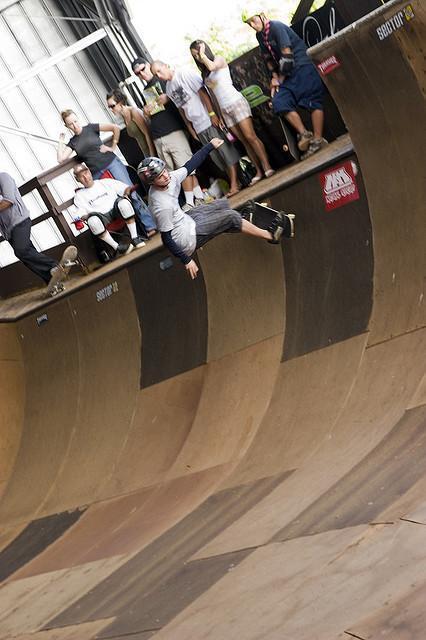What is the man skateboarding on?
Make your selection and explain in format: 'Answer: answer
Rationale: rationale.'
Options: Half pipe, training ramp, full pipe, tech deck. Answer: half pipe.
Rationale: The skating surface curves sharply upward at least at one end of it, and is roughly the height of an adult person at its highest point. 